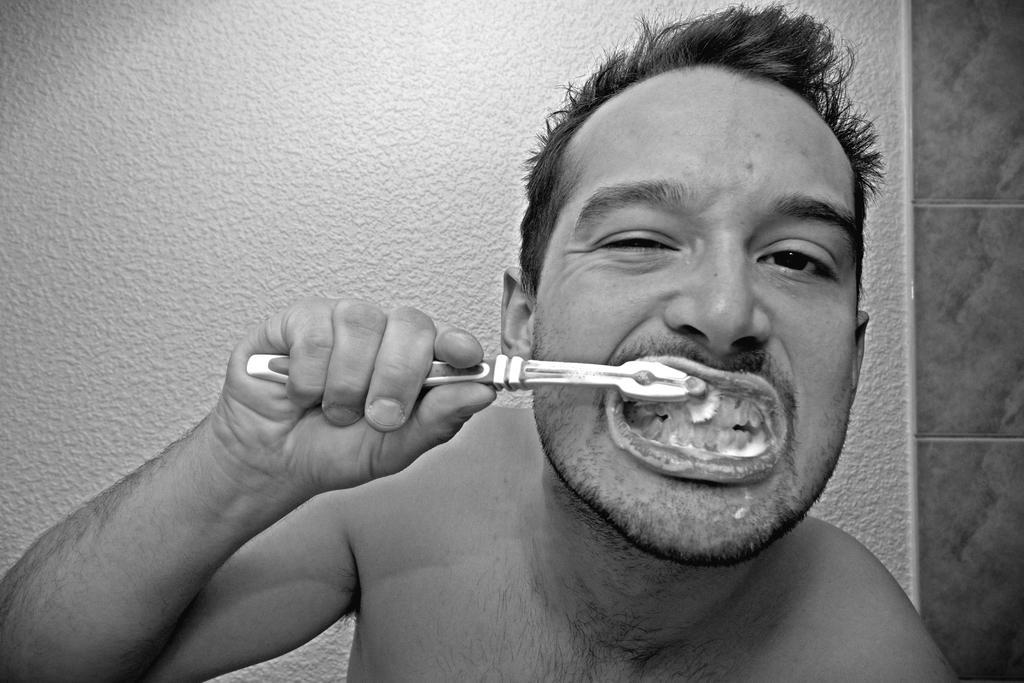Describe this image in one or two sentences. In this image in the front there is a man brushing his teeth. In the background there is wall. 